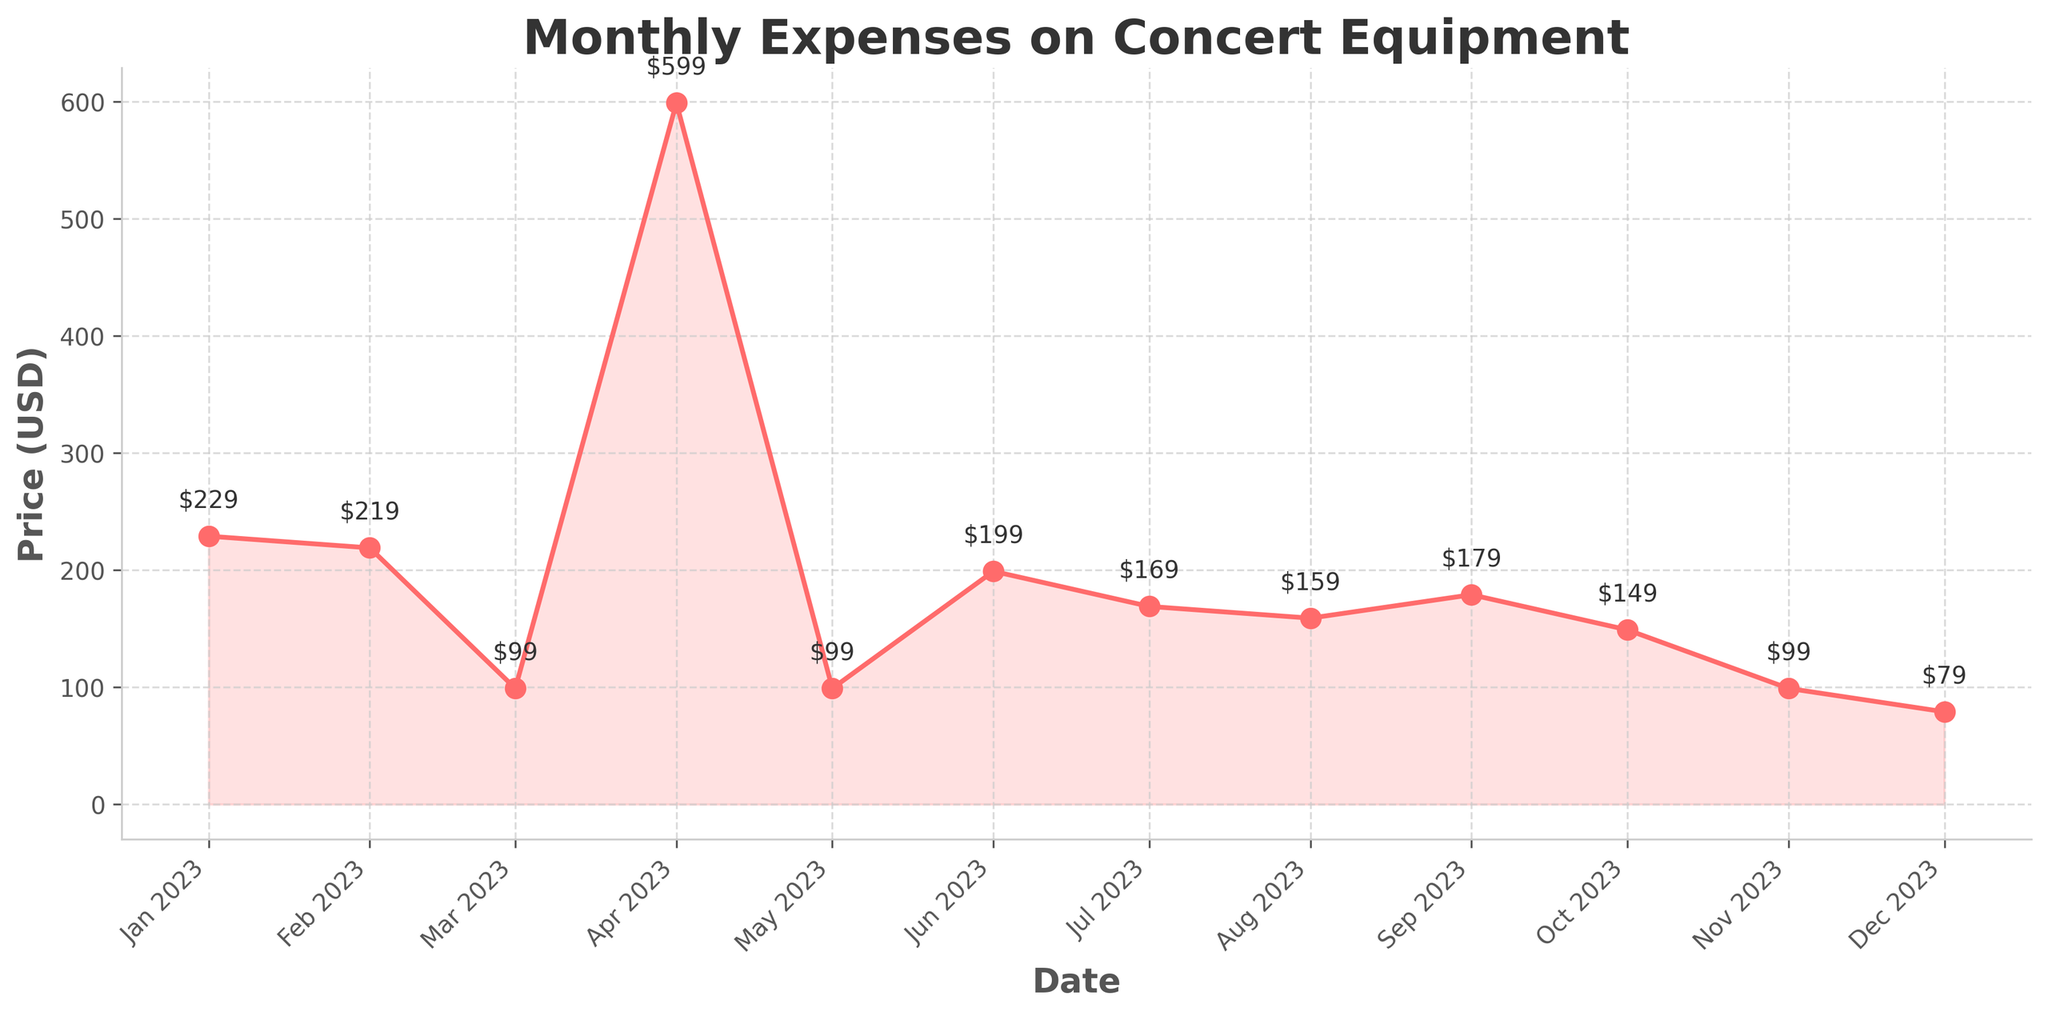What's the title of the plot? The title of the plot is located at the top of the figure and describes the main subject of the data being visualized.
Answer: Monthly Expenses on Concert Equipment What is the price of the most expensive item? The data points on the plot have prices annotated next to them. The highest price among the annotations will be the price of the most expensive item.
Answer: 599 Which month had the lowest expense, and what was the cost? Identify the lowest data point in the plot, noting its position on the x-axis, which represents the months, and the price annotation next to it.
Answer: December, 79 What is the total expense over the 12 months? To find the total expense, sum the annotated prices on each data point. The plot has 12 data points, representing each month.
Answer: 2178 How much did the expenses increase from February to March? Look at the annotations next to the February and March data points, then subtract the February price from the March price.
Answer: -120 What is the average monthly expense on concert equipment? Sum all the monthly expenses, then divide the total by 12 (the number of months). The total earlier was found to be 2178.
Answer: 181.5 By how much did the expenses vary in August compared to the overall average? Calculate the average monthly expense as previously found (181.5), then subtract the August expense from this average.
Answer: -22.5 Which month saw the highest expense on a recording device, and what was the cost? Identify the data points corresponding to recorders in which the descriptions or annotations to find the highest price.
Answer: April, 599 Compared to January, by what amount did the expense decrease or increase in July? Look at the January and July data points, determine their prices, and calculate the difference.
Answer: -60 What was the difference in expense between the cheapest microphone and the most expensive microphone? Identify the data points corresponding to microphones, find the highest and lowest prices among them, and calculate the difference.
Answer: 130 